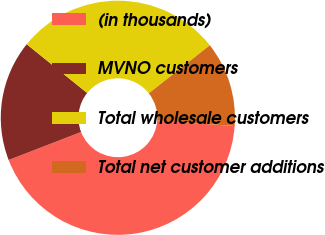<chart> <loc_0><loc_0><loc_500><loc_500><pie_chart><fcel>(in thousands)<fcel>MVNO customers<fcel>Total wholesale customers<fcel>Total net customer additions<nl><fcel>43.01%<fcel>16.68%<fcel>28.57%<fcel>11.74%<nl></chart> 